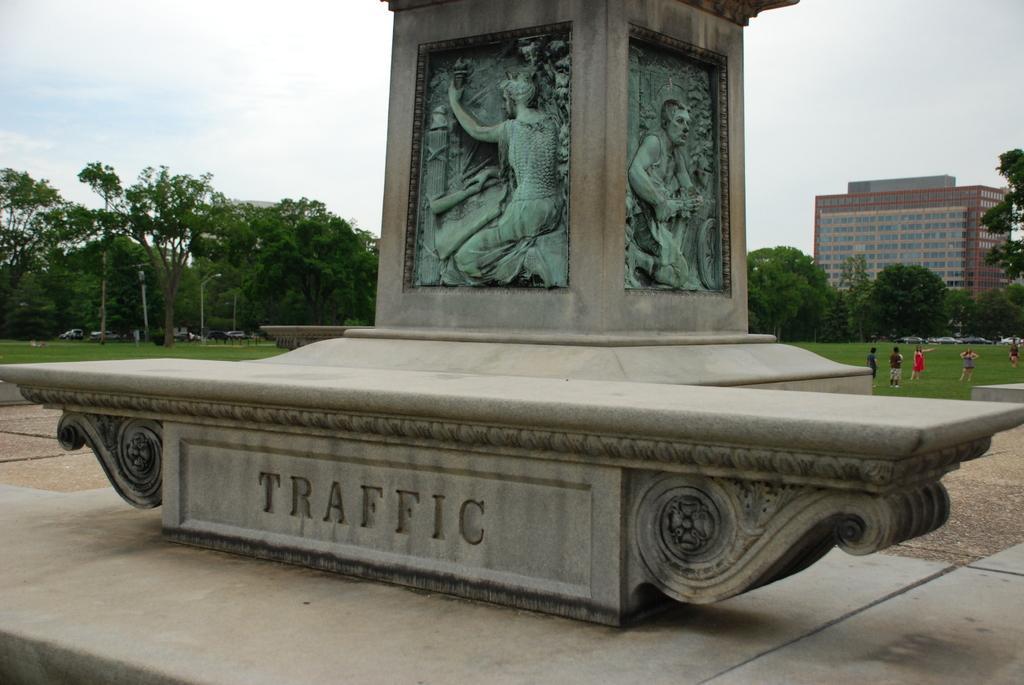Please provide a concise description of this image. In this image I can see two statues. In the background, I can see some people. I can also see the trees and a building. At the top I can see the clouds in the sky. 